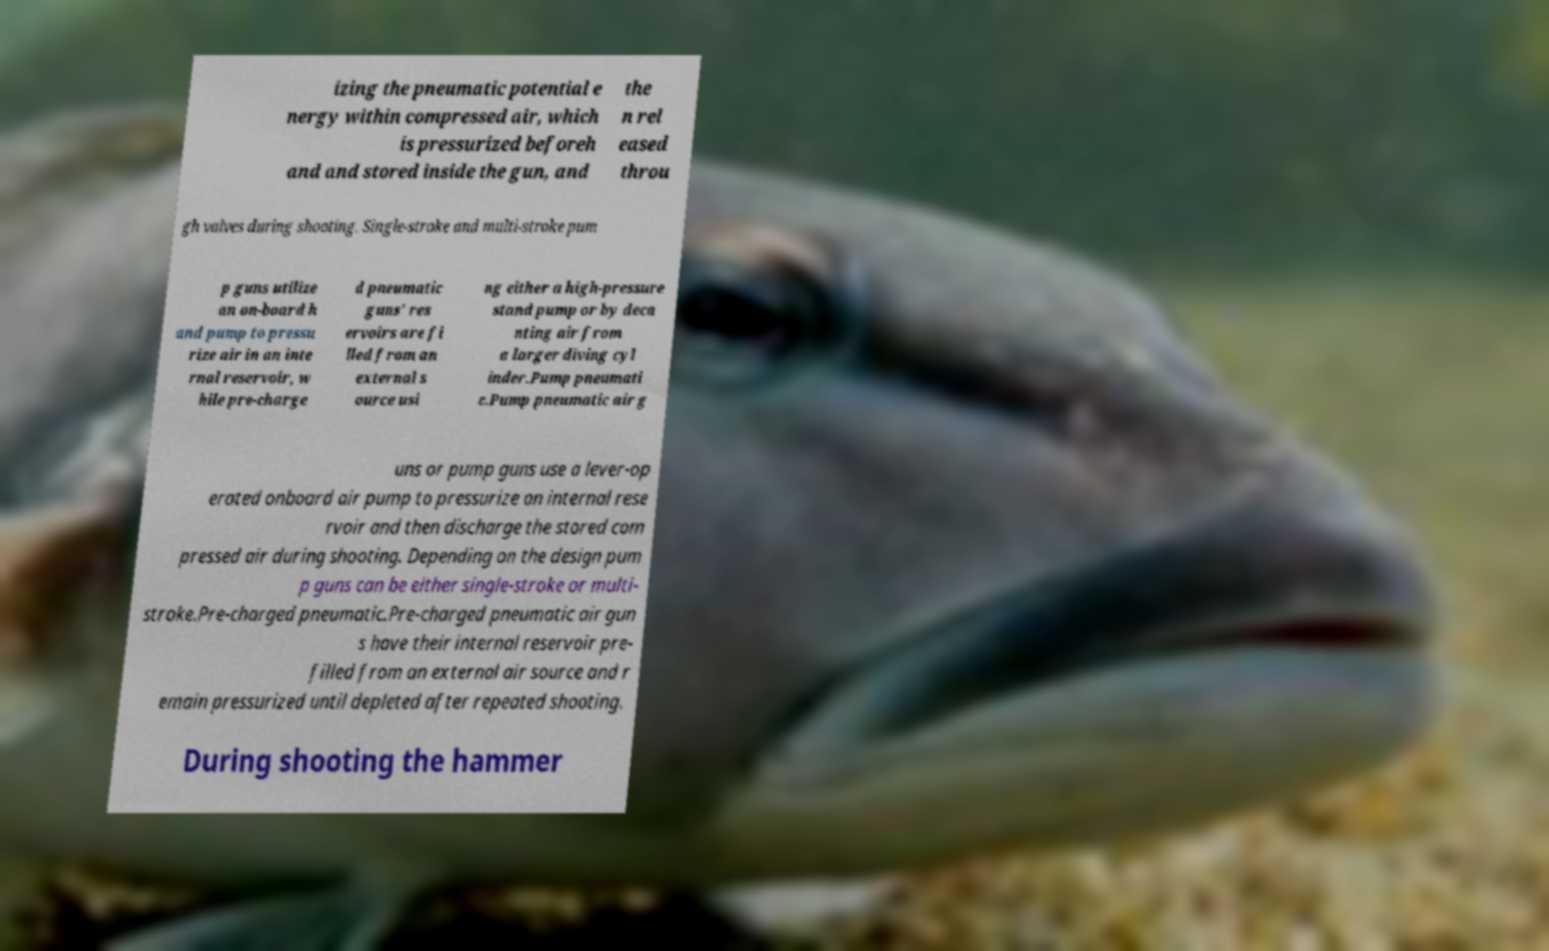Could you extract and type out the text from this image? izing the pneumatic potential e nergy within compressed air, which is pressurized beforeh and and stored inside the gun, and the n rel eased throu gh valves during shooting. Single-stroke and multi-stroke pum p guns utilize an on-board h and pump to pressu rize air in an inte rnal reservoir, w hile pre-charge d pneumatic guns' res ervoirs are fi lled from an external s ource usi ng either a high-pressure stand pump or by deca nting air from a larger diving cyl inder.Pump pneumati c.Pump pneumatic air g uns or pump guns use a lever-op erated onboard air pump to pressurize an internal rese rvoir and then discharge the stored com pressed air during shooting. Depending on the design pum p guns can be either single-stroke or multi- stroke.Pre-charged pneumatic.Pre-charged pneumatic air gun s have their internal reservoir pre- filled from an external air source and r emain pressurized until depleted after repeated shooting. During shooting the hammer 